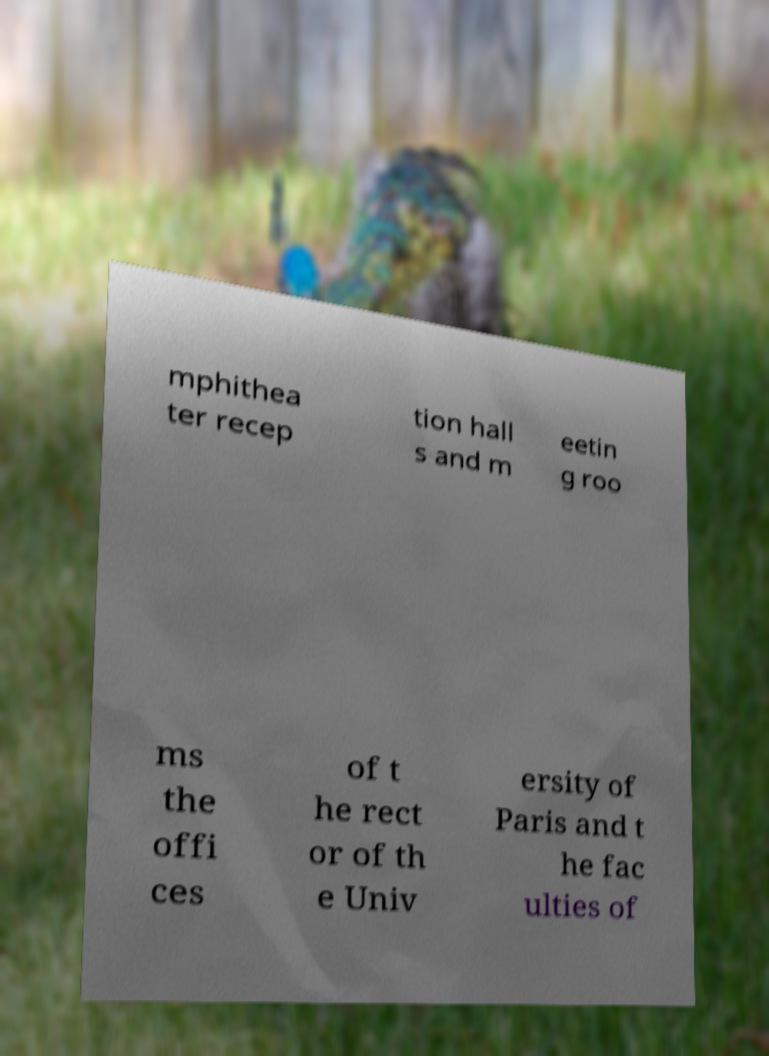There's text embedded in this image that I need extracted. Can you transcribe it verbatim? mphithea ter recep tion hall s and m eetin g roo ms the offi ces of t he rect or of th e Univ ersity of Paris and t he fac ulties of 